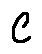<formula> <loc_0><loc_0><loc_500><loc_500>C</formula> 